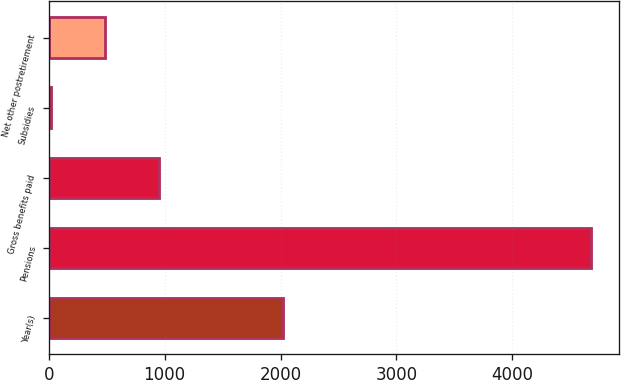Convert chart to OTSL. <chart><loc_0><loc_0><loc_500><loc_500><bar_chart><fcel>Year(s)<fcel>Pensions<fcel>Gross benefits paid<fcel>Subsidies<fcel>Net other postretirement<nl><fcel>2021<fcel>4684<fcel>950.4<fcel>17<fcel>483.7<nl></chart> 